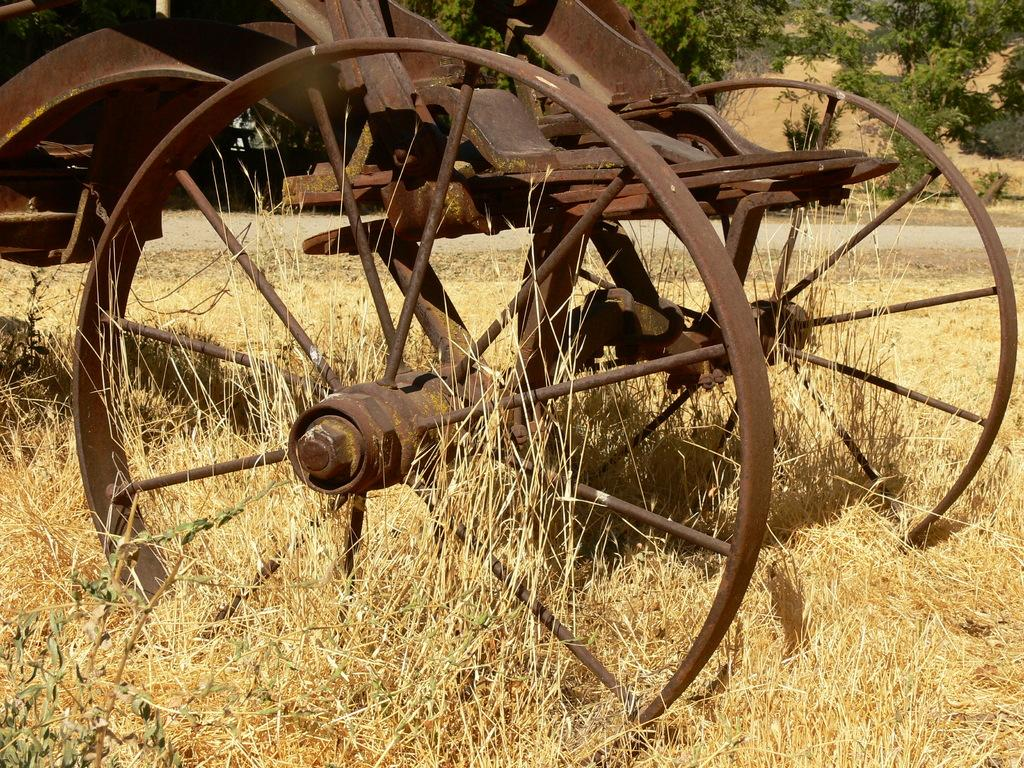What is the condition of the vehicle in the image? The vehicle in the image is rusted. What is the vehicle resting on in the image? The vehicle is on dried grass. What can be seen in the background of the image? There are trees in the background of the image. What type of current is flowing through the vehicle in the image? There is no indication of any current, electrical or otherwise, flowing through the vehicle in the image. What type of flock is visible in the image? There is no flock of animals or birds visible in the image; it features a rusted vehicle on dried grass with trees in the background. 